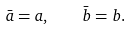<formula> <loc_0><loc_0><loc_500><loc_500>\bar { a } = a , \quad \bar { b } = b .</formula> 